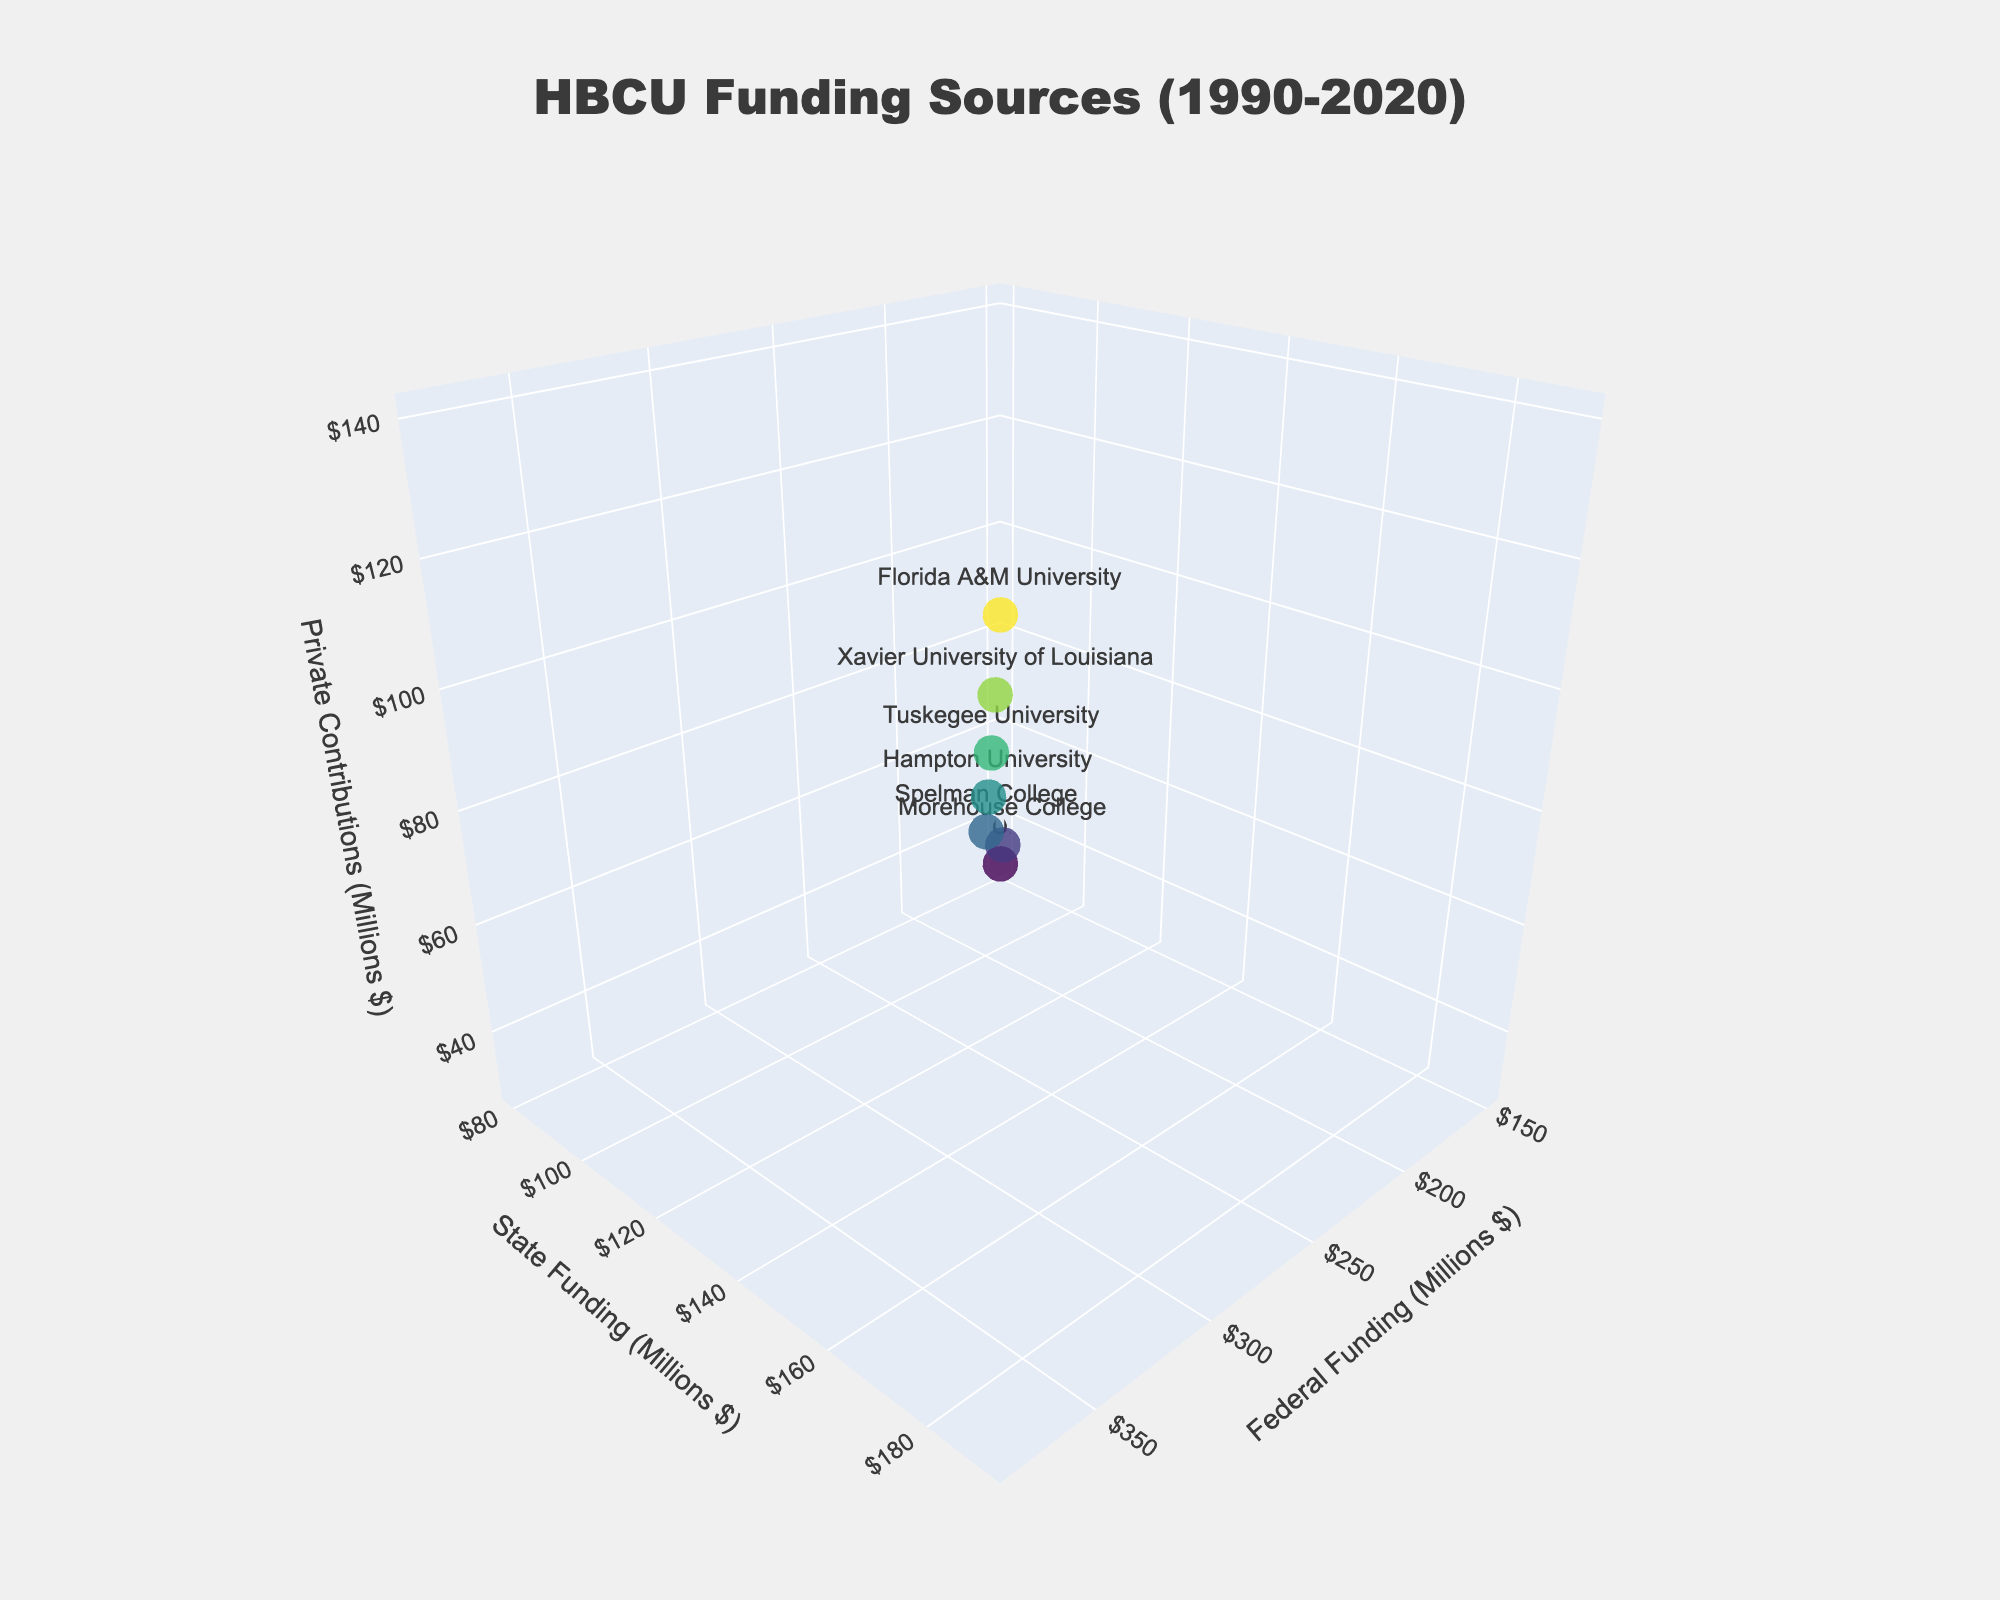What is the title of the 3D plot? The title of the plot is shown at the top and centers around the topic of funding sources for HBCUs.
Answer: HBCU Funding Sources (1990-2020) What is the range of Federal Funding displayed on the x-axis? By looking at the x-axis, the Federal Funding ranges from around the values corresponding to the data points in the table, starting from 150M to 380M.
Answer: 150M to 380M Which institution received the highest Private Contributions in 2020? The Private Contributions for 2020 and the corresponding institution can be identified from the markers in the 3D plot. The highest contribution in 2020 is attributed to the data point with the highest Private Contributions value, which corresponds to Florida A&M University.
Answer: Florida A&M University How have Federal Funding and State Funding values changed from 1990 to 2020? By comparing the positions of the data points from 1990 and 2020, Federal Funding increased from 150M to 380M, and State Funding increased from 80M to 190M, showing a clear upward trend.
Answer: Both Federal Funding and State Funding increased Which institutions are represented by the two data points with the highest State Funding figures? The two highest State Funding figures can be seen by identifying the two highest points along the y-axis, which correspond to Xavier University of Louisiana and Florida A&M University.
Answer: Xavier University of Louisiana and Florida A&M University What is the overall trend of Private Contributions from 1990 to 2020? Observing the z-axis, the Private Contributions values rise steadily from 30M in 1990 to 140M in 2020.
Answer: Increasing trend Which institution had the lowest funding in all three sources combined in any visible year? To find this, one would need to sum the Federal, State, and Private funding for each institution. The smallest combined fund would be Howard University in 1990, with a total of 260M.
Answer: Howard University in 1990 Are there any points where Private Contributions are greater than State Funding? By comparing the z-values (Private Contributions) and y-values (State Funding) for each data point, in all given years (data points), State Funding is consistently higher than Private Contributions.
Answer: No Which year's data point is closest to the origin in the 3D plot? The data point closest to the origin would have the smallest combined values of Federal Funding, State Funding, and Private Contributions. In this case, it is the 1990 data point for Howard University.
Answer: 1990 What is the overall shape formed by the plotted data points in 3D space? Observing the 3D scatter plot, the data points form an upward-sloping pattern over the years, indicating a trend of increasing funding across all sources.
Answer: Upward-sloping pattern 